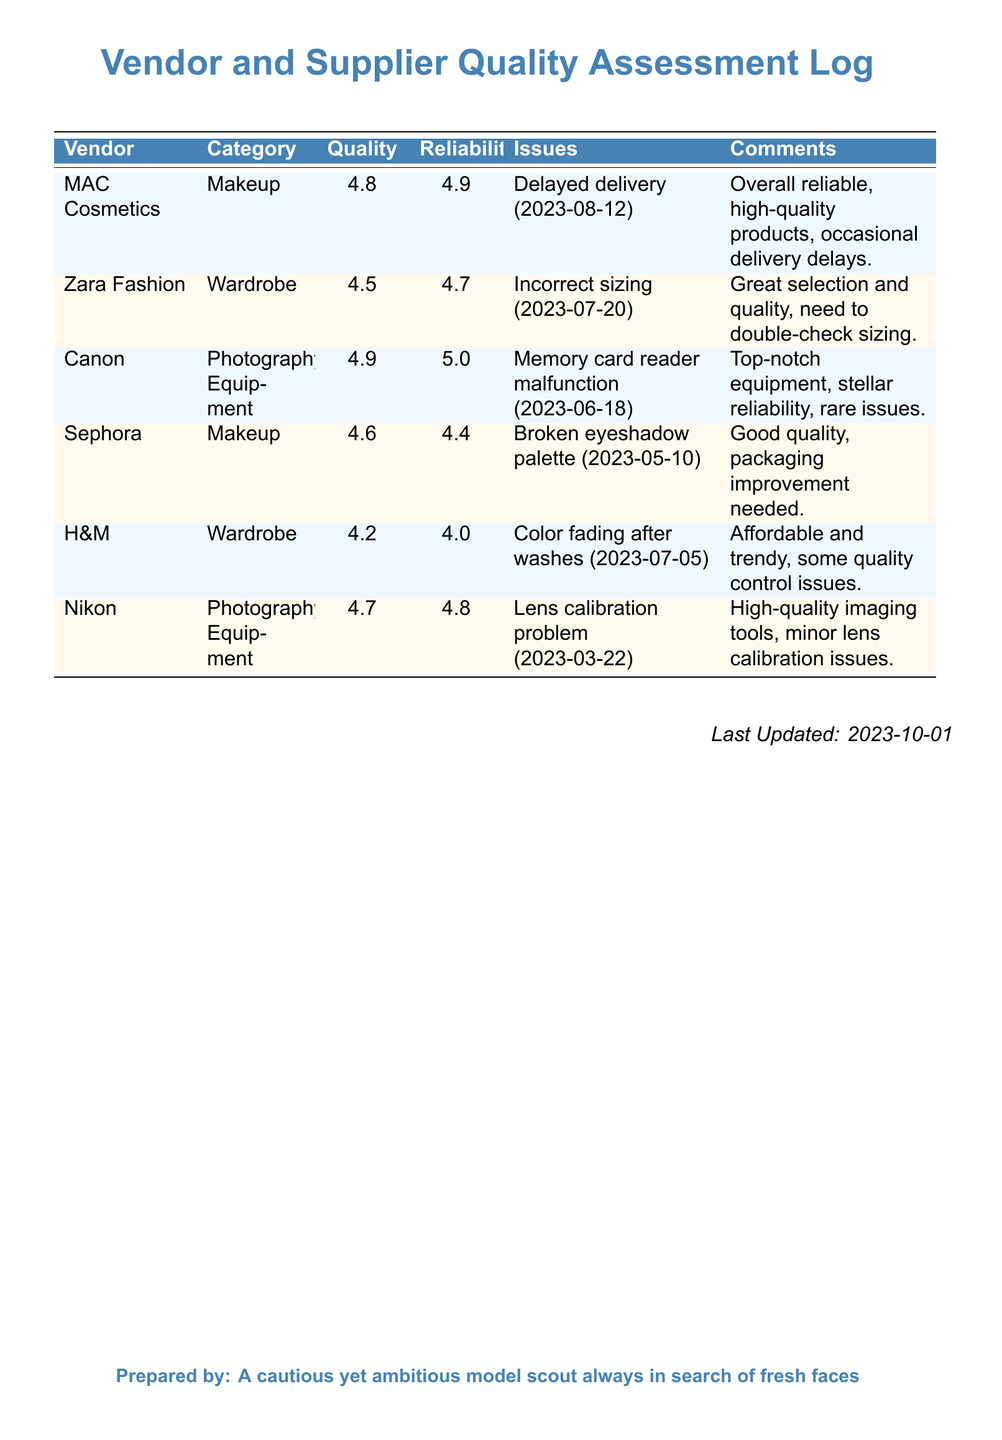What is the highest quality rating among vendors? The quality ratings for vendors are specified in the document, with MAC Cosmetics having the highest quality rating of 4.8.
Answer: 4.8 Which vendor has the lowest reliability rating? The reliability ratings for the vendors are included, with H&M having the lowest reliability rating of 4.0.
Answer: 4.0 What issue did Sephora encounter? Sephora had a broken eyeshadow palette listed as an issue in the log.
Answer: Broken eyeshadow palette Which vendor received a comment about occasional delivery delays? The comment about occasional delivery delays pertains to MAC Cosmetics, indicating reliability but occasional delays.
Answer: MAC Cosmetics What category does Nikon belong to? Nikon is categorized under photography equipment within the vendor assessment log.
Answer: Photography Equipment Which vendor had an issue with incorrect sizing and when? Zara Fashion encountered an issue with incorrect sizing on 2023-07-20, as noted in the log.
Answer: Incorrect sizing (2023-07-20) How often does Canon have issues according to the log? Canon is noted for having rare issues and overall top-notch reliability in the document.
Answer: Rare issues What date was the log last updated? The last updated date of the log is explicitly mentioned in the document as 2023-10-01.
Answer: 2023-10-01 What quality rating did H&M receive? The quality rating for H&M is provided in the document as 4.2.
Answer: 4.2 